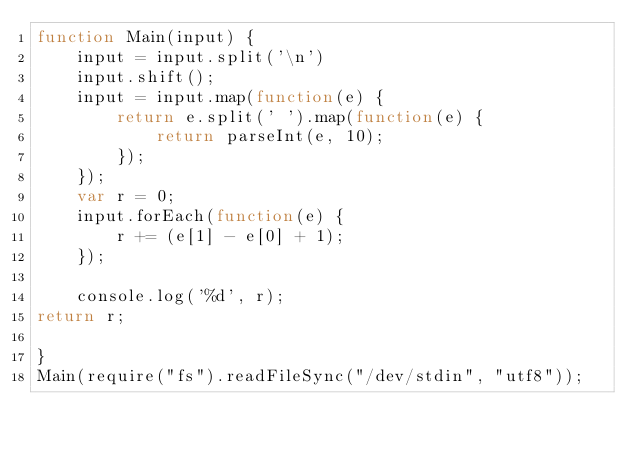Convert code to text. <code><loc_0><loc_0><loc_500><loc_500><_JavaScript_>function Main(input) {
    input = input.split('\n')
    input.shift();
    input = input.map(function(e) {
        return e.split(' ').map(function(e) {
            return parseInt(e, 10);
        });
    });
    var r = 0;
    input.forEach(function(e) {
        r += (e[1] - e[0] + 1);
    });

    console.log('%d', r);
return r;

}
Main(require("fs").readFileSync("/dev/stdin", "utf8"));
</code> 